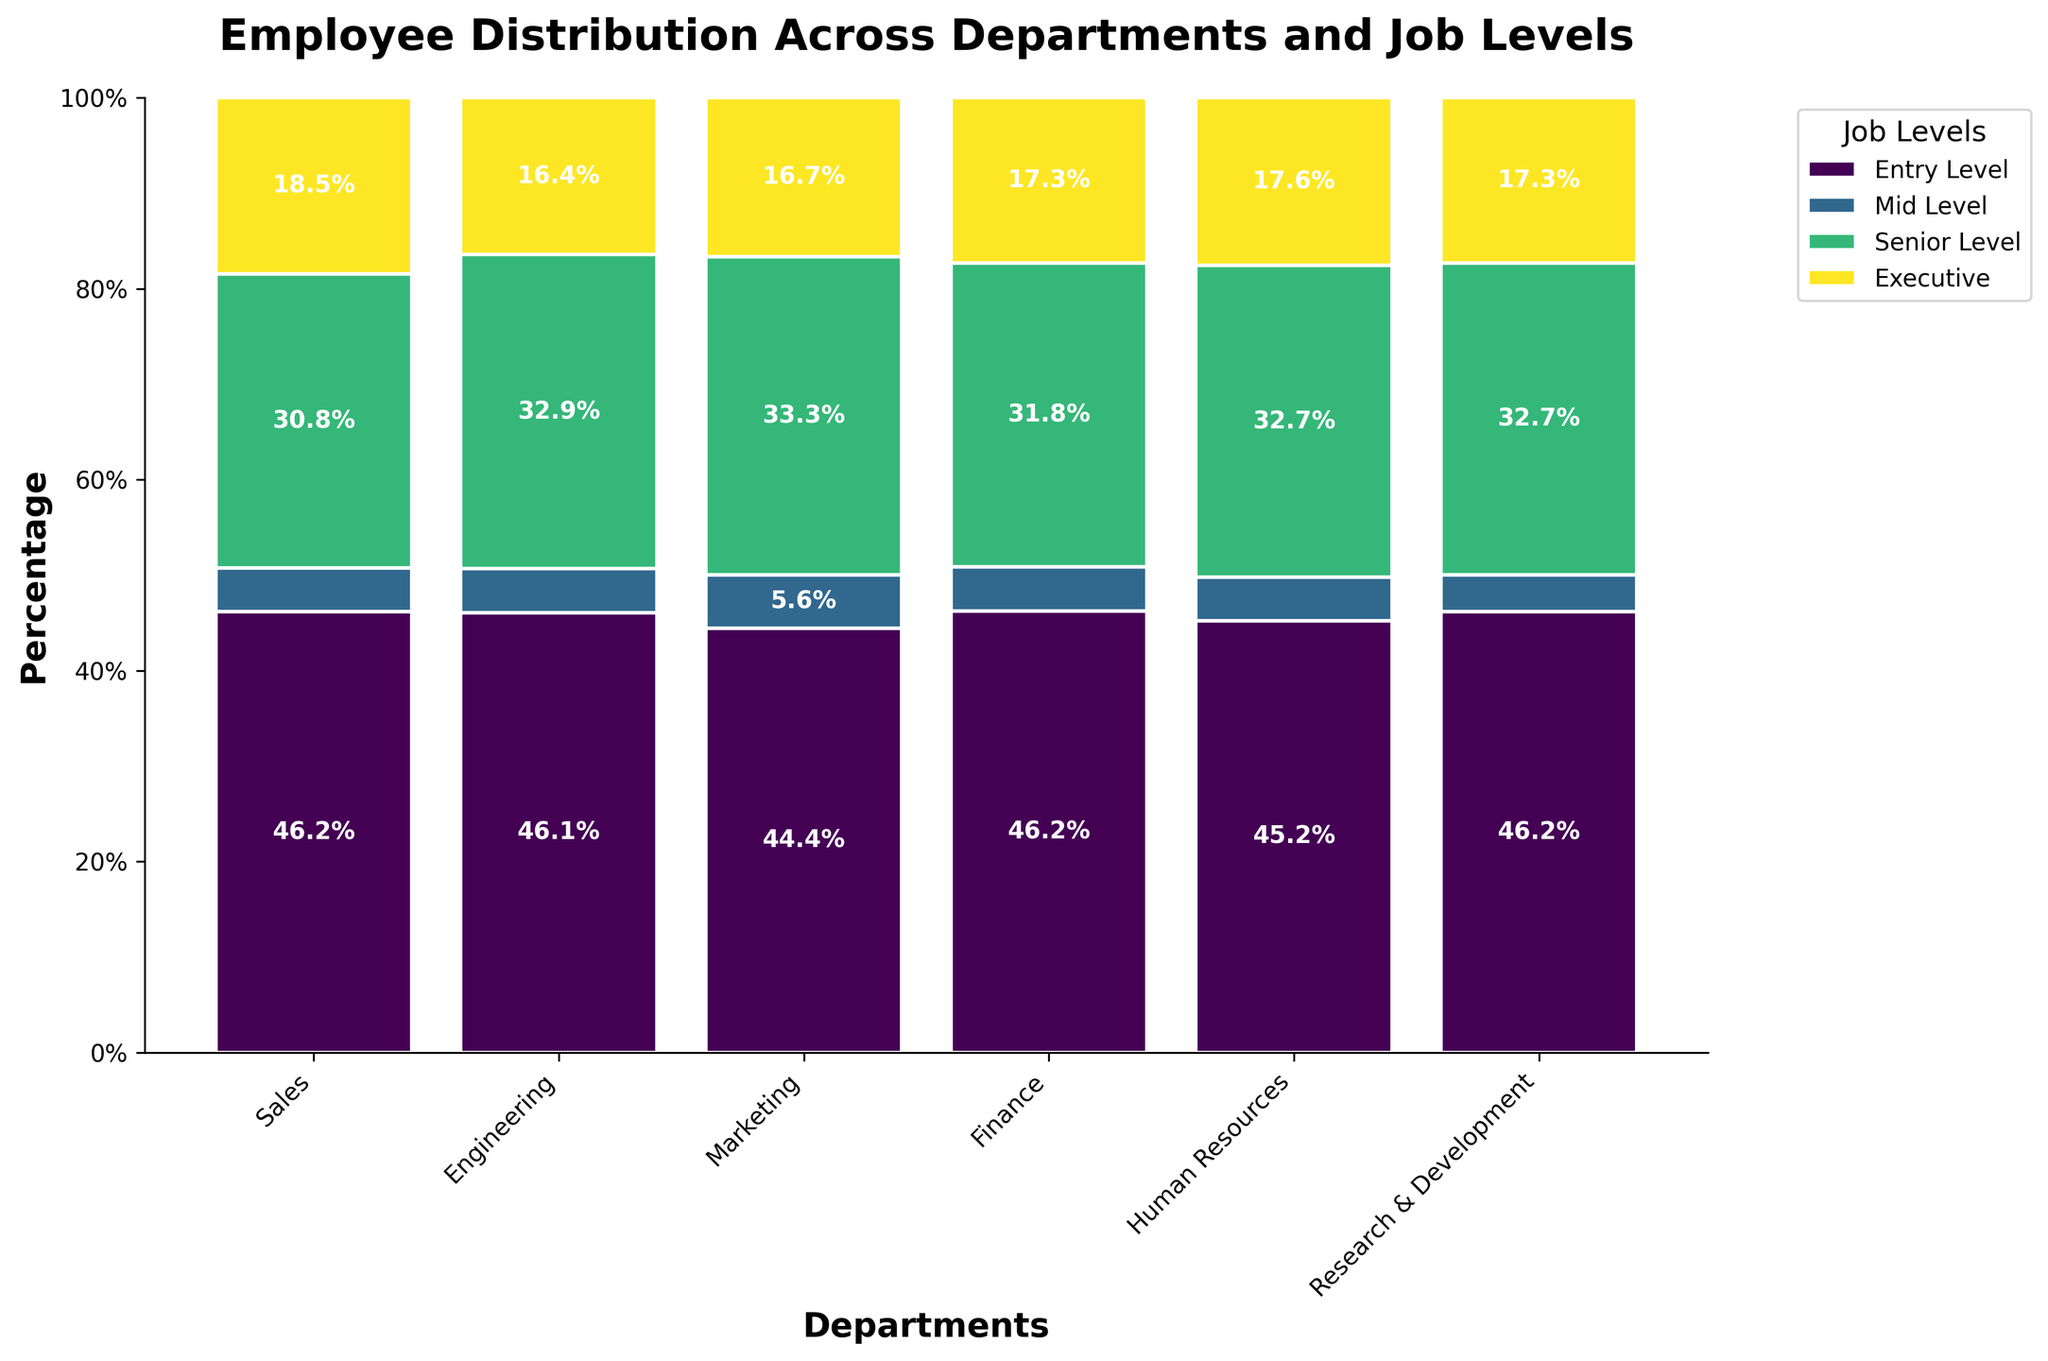What's the title of the plot? The title of the plot is usually displayed prominently at the top of the figure. Here, the title reads "Employee Distribution Across Departments and Job Levels".
Answer: Employee Distribution Across Departments and Job Levels Which department has the highest percentage of Entry Level employees? To find this, look at the bar segments representing Entry Level employees (likely the bottom segments) and compare their heights. Engineering has the highest percentage for Entry Level.
Answer: Engineering What percentage of employees in Finance are at the Executive level? Look at the Executive level section of the Finance bar. The percentage label for this segment reads 5.0%.
Answer: 5.0% Which department has the smallest proportion of Senior Level employees? Compare the heights of the Senior Level segments across all departments. Human Resources has the smallest proportion.
Answer: Human Resources What's the percentage of Mid Level employees in Research & Development? Check the Mid Level segment of the Research & Development bar, the percentage label reads 33.3%.
Answer: 33.3% Which two departments have the closest percentage of Senior Level employees? Compare the Senior Level segments to identify the two departments with similar heights. Finance and Marketing have close proportions with 25.0% and 23.3%, respectively.
Answer: Finance and Marketing Is the percentage of Executive employees higher in Sales or Engineering? Compare the top segments of the Sales and Engineering bars. Engineering has a higher percentage (5.0%) compared to Sales (3.7%).
Answer: Engineering What is the total percentage of Mid Level and Senior Level employees in Marketing? Sum the percentages for Mid Level (30.6%) and Senior Level (16.7%) employees in Marketing. The total is 47.2%.
Answer: 47.2% Which department has the least percentage of Mid Level employees? Compare the Mid Level segments and identify the shortest one. Human Resources has the least percentage (30.0%).
Answer: Human Resources What is the combined percentage of Entry Level and Executive employees in the Sales department? Sum the percentages of Entry Level (48.0%) and Executive (4.0%) employees in Sales. The total is 52.0%.
Answer: 52.0% 